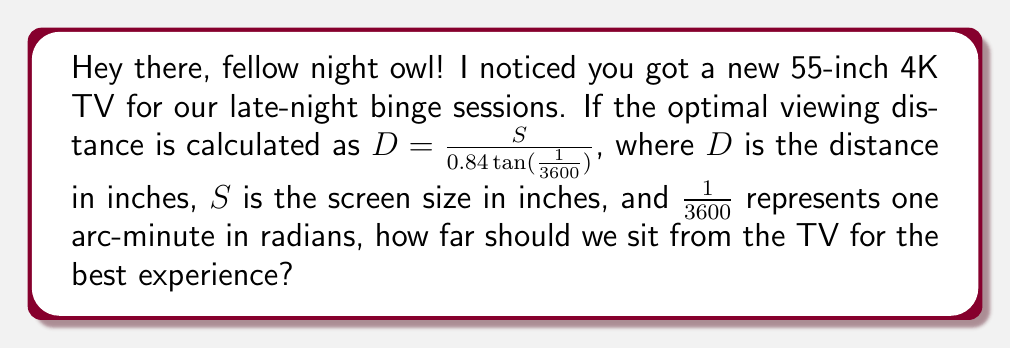Can you solve this math problem? Let's break this down step-by-step:

1) We're given the formula: $D = \frac{S}{0.84 \tan(\frac{1}{3600})}$

2) We know the screen size $S = 55$ inches (diagonal measurement of the TV)

3) Let's substitute this into our formula:
   $D = \frac{55}{0.84 \tan(\frac{1}{3600})}$

4) Now, let's calculate $\tan(\frac{1}{3600})$:
   $\tan(\frac{1}{3600}) \approx 0.0002908882086657216$

5) Substituting this value:
   $D = \frac{55}{0.84 \times 0.0002908882086657216}$

6) Simplifying:
   $D = \frac{55}{0.00024434609527920614}$

7) Calculating the final result:
   $D \approx 225.09$ inches

8) Converting to feet for practicality:
   $225.09 \div 12 \approx 18.76$ feet

Therefore, the optimal viewing distance for a 55-inch 4K TV is about 18.76 feet or roughly 19 feet.
Answer: 18.76 feet 